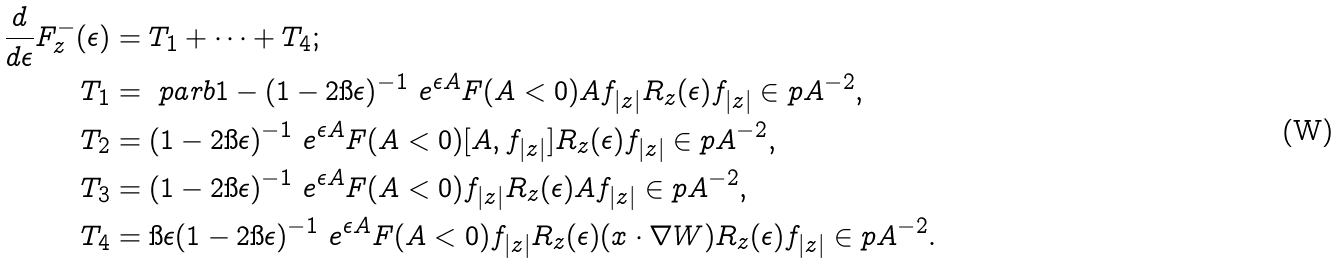Convert formula to latex. <formula><loc_0><loc_0><loc_500><loc_500>\frac { d } { d \epsilon } F ^ { - } _ { z } ( \epsilon ) & = T _ { 1 } + \cdots + T _ { 4 } ; \\ T _ { 1 } & = \ p a r b { 1 - ( 1 - 2 \i \epsilon ) ^ { - 1 } } \ e ^ { \epsilon A } F ( A < 0 ) A f _ { | z | } R _ { z } ( \epsilon ) f _ { | z | } \in p { A } ^ { - 2 } , \\ T _ { 2 } & = ( 1 - 2 \i \epsilon ) ^ { - 1 } \ e ^ { \epsilon A } F ( A < 0 ) [ A , f _ { | z | } ] R _ { z } ( \epsilon ) f _ { | z | } \in p { A } ^ { - 2 } , \\ T _ { 3 } & = ( 1 - 2 \i \epsilon ) ^ { - 1 } \ e ^ { \epsilon A } F ( A < 0 ) f _ { | z | } R _ { z } ( \epsilon ) A f _ { | z | } \in p { A } ^ { - 2 } , \\ T _ { 4 } & = \i \epsilon ( 1 - 2 \i \epsilon ) ^ { - 1 } \ e ^ { \epsilon A } F ( A < 0 ) f _ { | z | } R _ { z } ( \epsilon ) ( x \cdot \nabla W ) R _ { z } ( \epsilon ) f _ { | z | } \in p { A } ^ { - 2 } .</formula> 